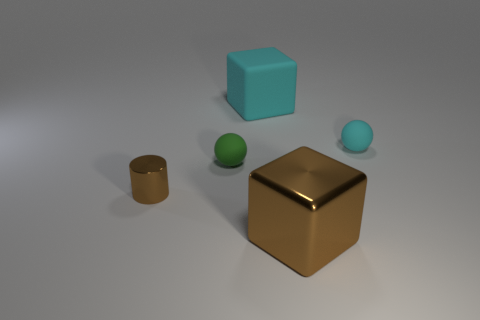Subtract all spheres. How many objects are left? 3 Add 2 big brown shiny blocks. How many big brown shiny blocks are left? 3 Add 5 big cyan matte blocks. How many big cyan matte blocks exist? 6 Add 4 cubes. How many objects exist? 9 Subtract 0 cyan cylinders. How many objects are left? 5 Subtract all red cubes. Subtract all cyan cylinders. How many cubes are left? 2 Subtract all green blocks. How many cyan spheres are left? 1 Subtract all small matte objects. Subtract all large purple metal things. How many objects are left? 3 